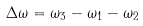<formula> <loc_0><loc_0><loc_500><loc_500>\Delta \omega = \omega _ { 3 } - \omega _ { 1 } - \omega _ { 2 }</formula> 